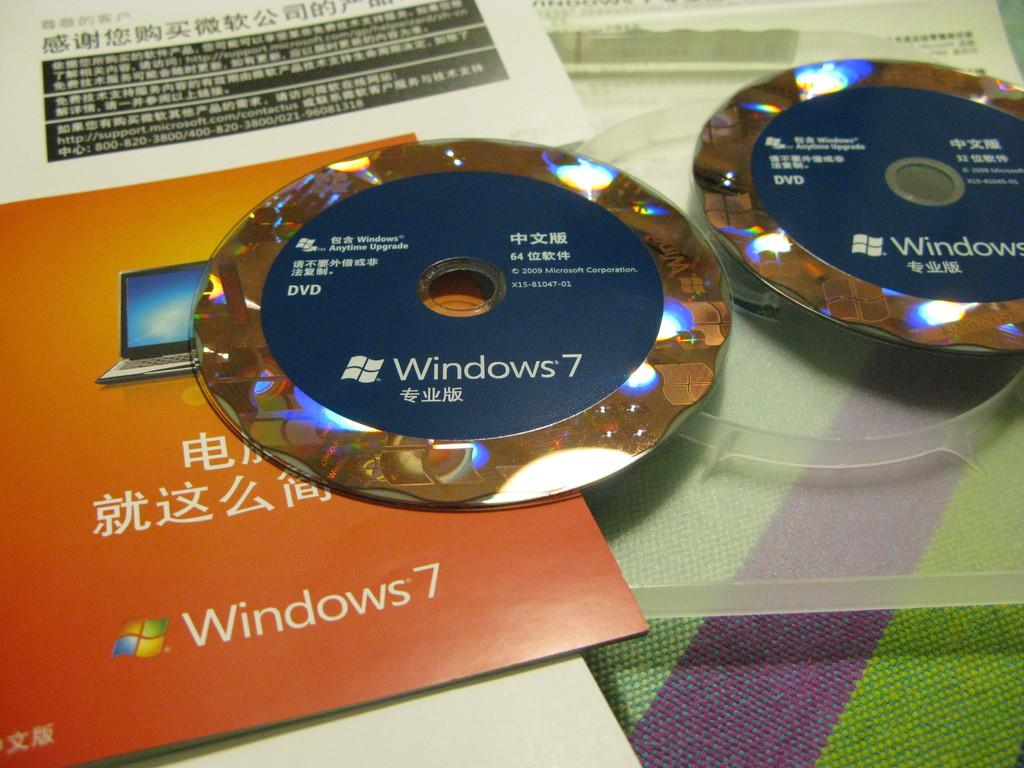Provide a one-sentence caption for the provided image. two windows 7 installation DVDs are on the top of the manuals in Chinese. 